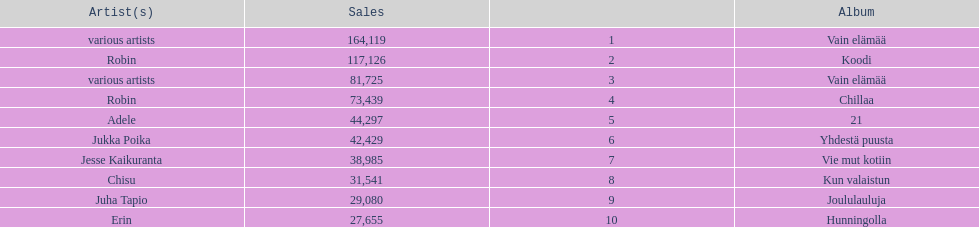What was the top selling album in this year? Vain elämää. 